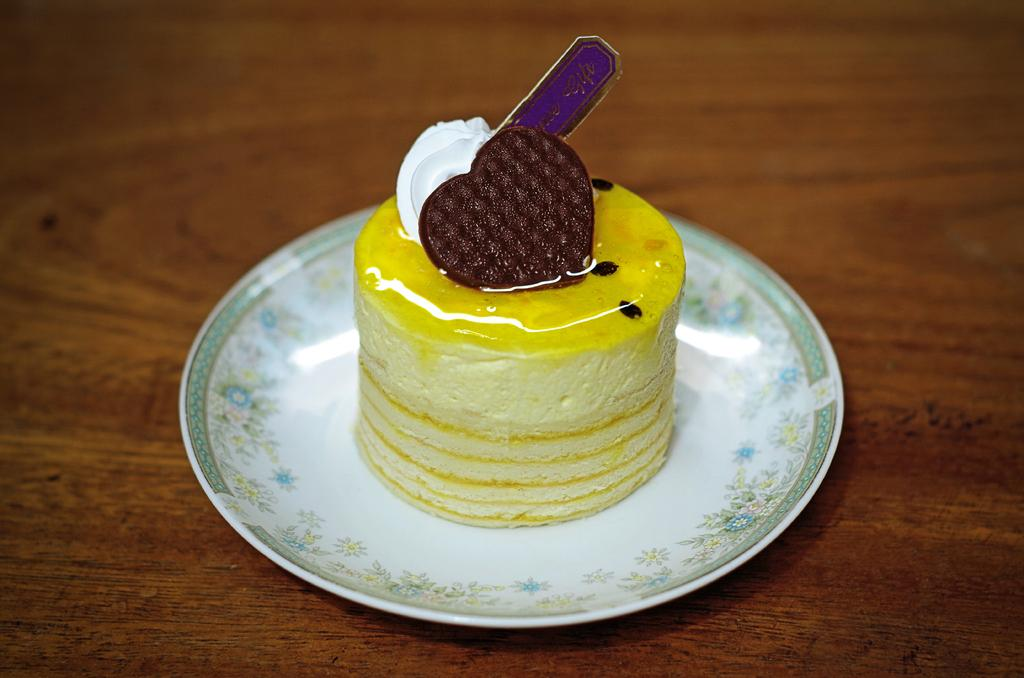What is on the plate that is visible in the image? There is a plate with food in the image. Can you describe the colors of the food on the plate? The food has yellow, brown, and white colors. What colors can be seen on the plate itself? The plate has blue, yellow, ash, and white colors. What is the color of the surface on which the plate is placed? The plate is on a brown surface. How does the wave affect the trade in the image? There is no wave or trade present in the image; it features a plate with food on a brown surface. 